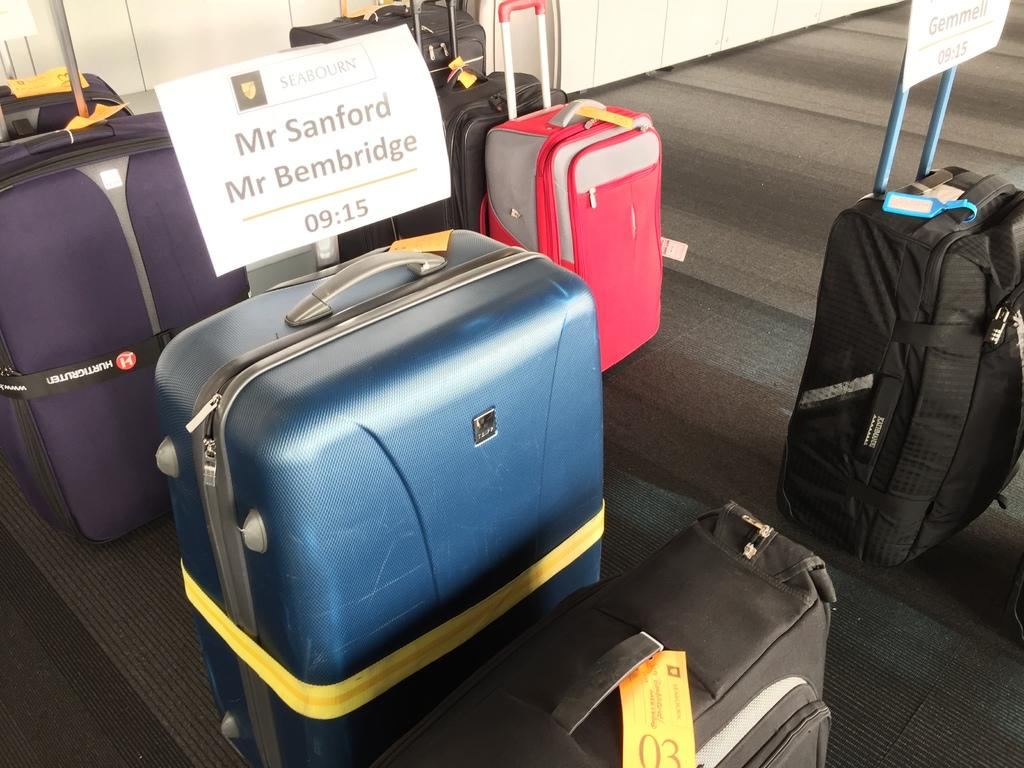What objects are present in the image? There are bags in the image. What is placed on the bags? There are two boards on the bags. What information is written on the boards? Names and numbers are written on the boards. What can be seen in the background of the image? There is a wall in the background of the image. What type of slope can be seen in the image? There is no slope present in the image. How does the image convey a sense of hate or dislike? The image does not convey any sense of hate or dislike; it only shows bags with boards and writing on them. 